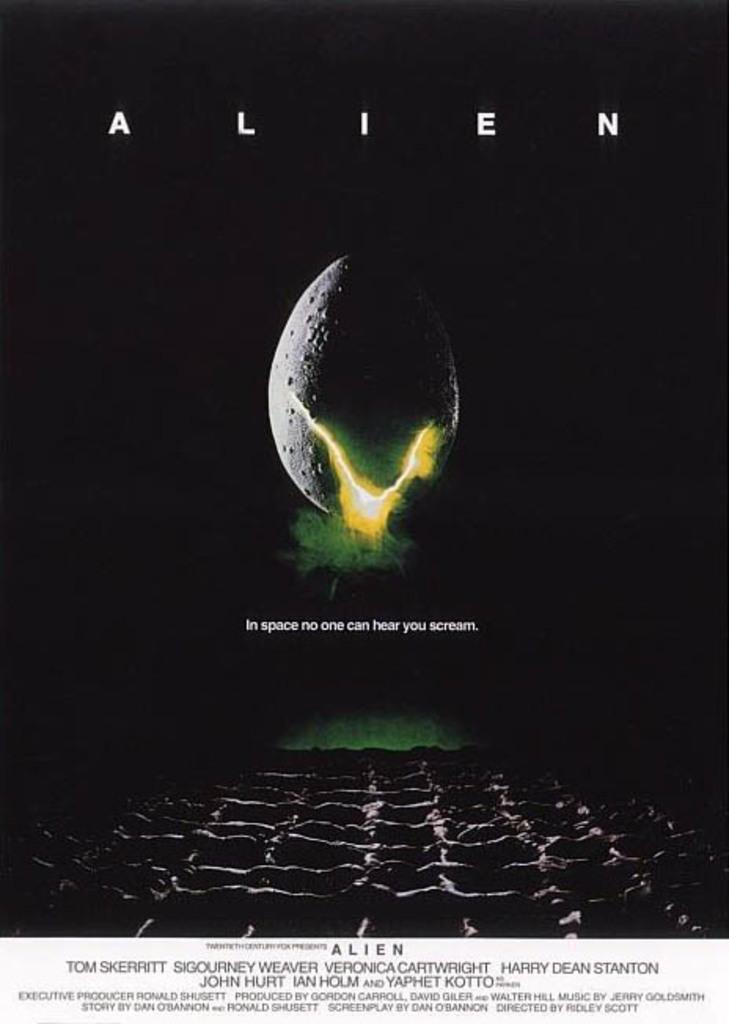<image>
Share a concise interpretation of the image provided. An advertisement that says ALIEN across the top and In space no one can hear you scream across the bottom. 